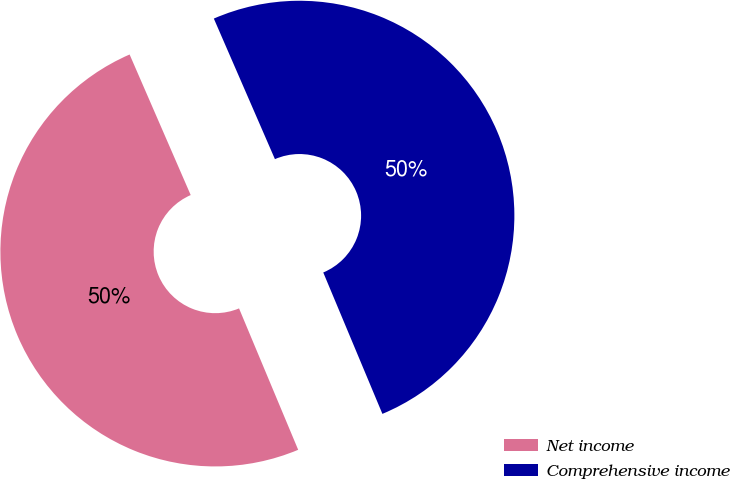<chart> <loc_0><loc_0><loc_500><loc_500><pie_chart><fcel>Net income<fcel>Comprehensive income<nl><fcel>49.78%<fcel>50.22%<nl></chart> 